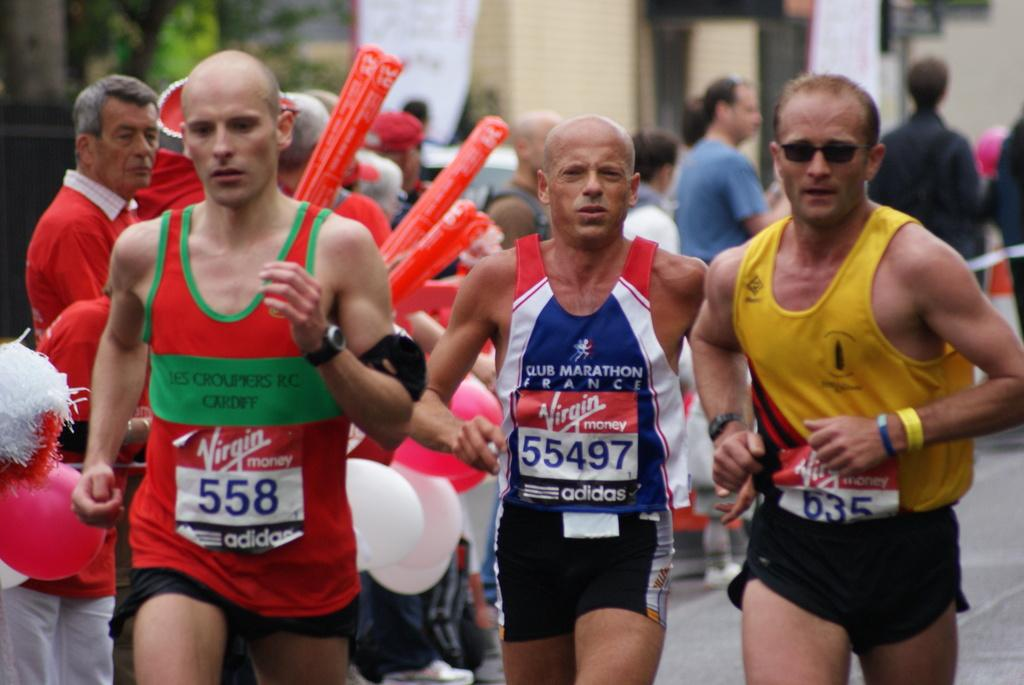Who or what can be seen in the image? There are people in the image. What else is present in the image besides people? There are balloons and unspecified objects in the image. What can be seen in the background of the image? There are banners, a wall, and trees in the background of the image. What type of rhythm can be heard from the cow in the image? There is no cow present in the image, so it is not possible to determine the rhythm. 